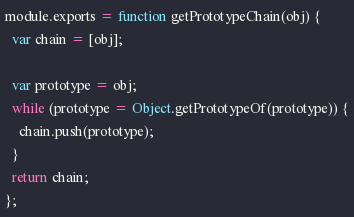<code> <loc_0><loc_0><loc_500><loc_500><_JavaScript_>module.exports = function getPrototypeChain(obj) {
  var chain = [obj];

  var prototype = obj;
  while (prototype = Object.getPrototypeOf(prototype)) {
    chain.push(prototype);
  }  
  return chain;
};
</code> 